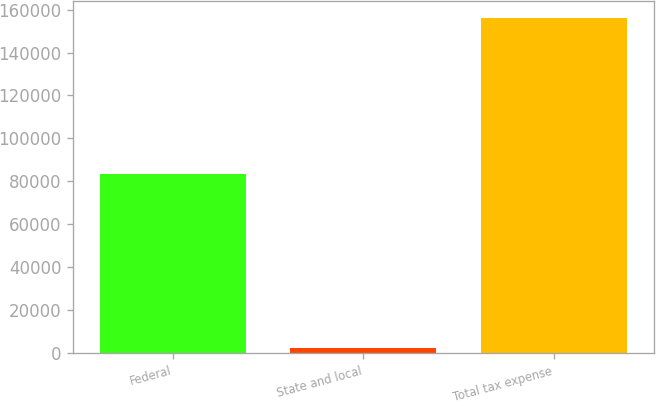Convert chart. <chart><loc_0><loc_0><loc_500><loc_500><bar_chart><fcel>Federal<fcel>State and local<fcel>Total tax expense<nl><fcel>83428<fcel>2433<fcel>156023<nl></chart> 